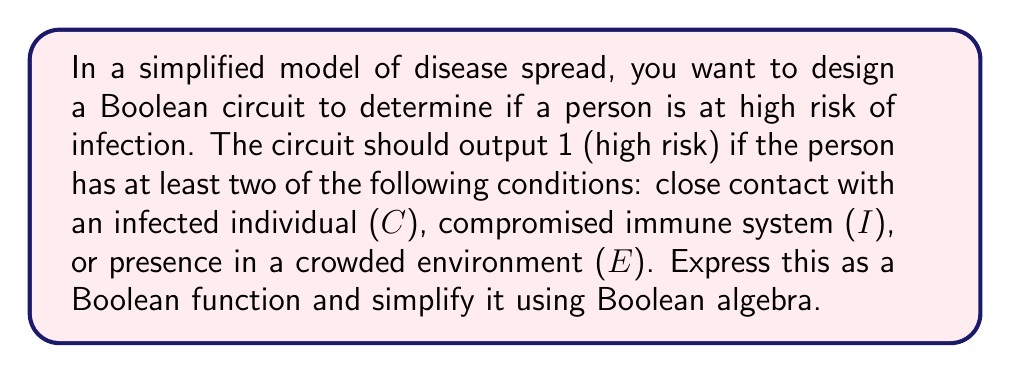Give your solution to this math problem. Let's approach this step-by-step:

1) First, we need to express the conditions as a Boolean function. We want the output to be 1 if at least two of the three conditions are true. This can be written as:

   $$ F = (C \cdot I) + (C \cdot E) + (I \cdot E) $$

2) This function is already in Sum of Products (SOP) form, but we can simplify it further using Boolean algebra laws.

3) Let's apply the distributive law:

   $$ F = C(I + E) + (I \cdot E) $$

4) Now, we can use the absorption law: $X + (X \cdot Y) = X$
   Here, $X = C(I + E)$ and $Y = I + E$

   $$ F = C(I + E) + (I \cdot E) = C(I + E) $$

5) This simplified form $C(I + E)$ is equivalent to our original function but uses fewer operations.

6) We can verify this simplification by creating a truth table or by logical reasoning: 
   The function will output 1 if C is true and either I or E (or both) are true, which indeed represents at least two conditions being true.

As a general practitioner, you could use this simplified Boolean function to quickly assess a patient's risk level during a family gathering, considering their contact history, immune status, and environmental exposure.
Answer: $F = C(I + E)$ 